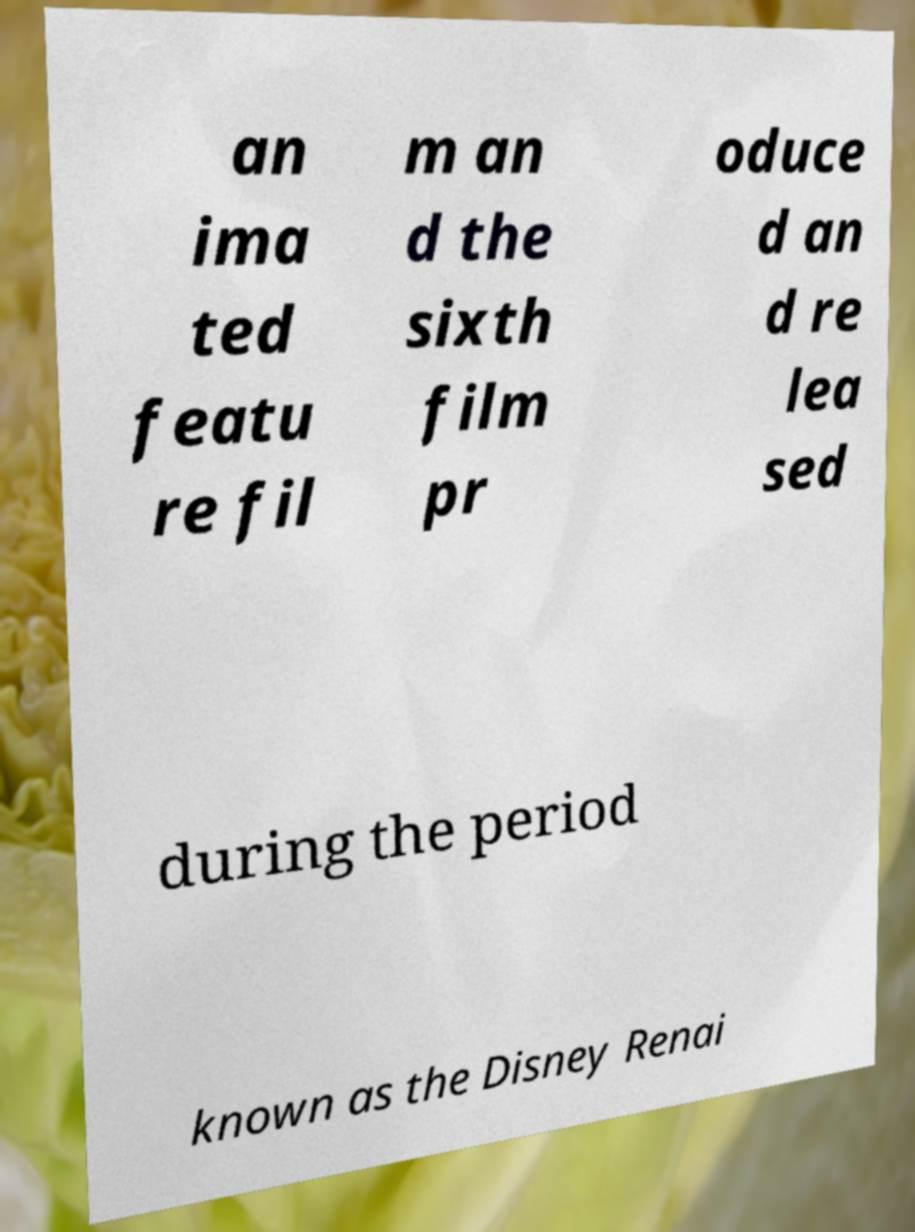Please identify and transcribe the text found in this image. an ima ted featu re fil m an d the sixth film pr oduce d an d re lea sed during the period known as the Disney Renai 